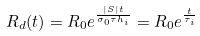<formula> <loc_0><loc_0><loc_500><loc_500>R _ { d } ( t ) = R _ { 0 } e ^ { \frac { | S | t } { \sigma _ { 0 } \tau h _ { i } } } = R _ { 0 } e ^ { \frac { t } { \tau _ { i } } }</formula> 